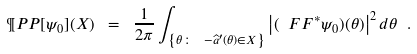<formula> <loc_0><loc_0><loc_500><loc_500>\P P P [ \psi _ { 0 } ] ( X ) \ = \ \frac { 1 } { 2 \pi } \int _ { \left \{ \theta \colon \ - \widehat { a } ^ { \prime } ( \theta ) \in X \right \} } \left | ( \ F F ^ { * } \psi _ { 0 } ) ( \theta ) \right | ^ { 2 } d \theta \ .</formula> 